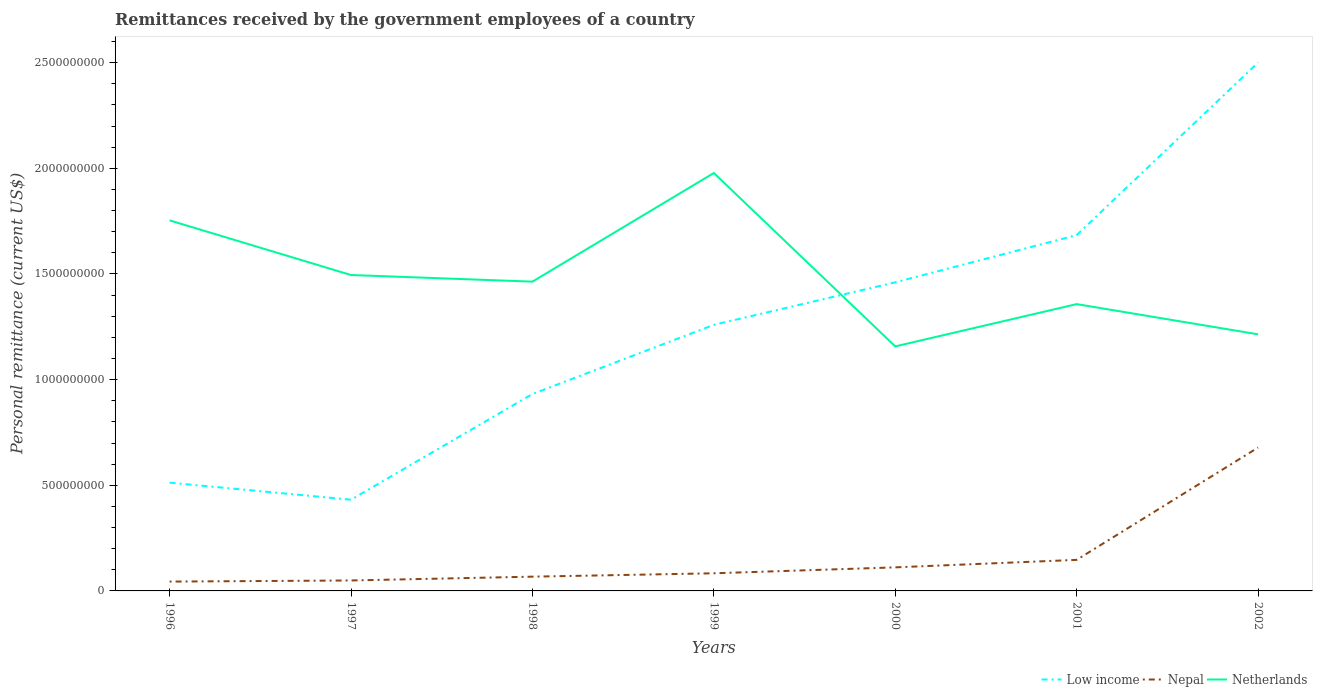Across all years, what is the maximum remittances received by the government employees in Netherlands?
Make the answer very short. 1.16e+09. In which year was the remittances received by the government employees in Low income maximum?
Ensure brevity in your answer.  1997. What is the total remittances received by the government employees in Netherlands in the graph?
Provide a succinct answer. 7.63e+08. What is the difference between the highest and the second highest remittances received by the government employees in Netherlands?
Offer a terse response. 8.21e+08. Is the remittances received by the government employees in Nepal strictly greater than the remittances received by the government employees in Netherlands over the years?
Your answer should be very brief. Yes. How many lines are there?
Provide a succinct answer. 3. How many years are there in the graph?
Offer a terse response. 7. What is the difference between two consecutive major ticks on the Y-axis?
Offer a terse response. 5.00e+08. Are the values on the major ticks of Y-axis written in scientific E-notation?
Ensure brevity in your answer.  No. Does the graph contain any zero values?
Offer a very short reply. No. Does the graph contain grids?
Give a very brief answer. No. What is the title of the graph?
Give a very brief answer. Remittances received by the government employees of a country. What is the label or title of the X-axis?
Give a very brief answer. Years. What is the label or title of the Y-axis?
Your answer should be very brief. Personal remittance (current US$). What is the Personal remittance (current US$) in Low income in 1996?
Provide a short and direct response. 5.12e+08. What is the Personal remittance (current US$) of Nepal in 1996?
Your response must be concise. 4.42e+07. What is the Personal remittance (current US$) of Netherlands in 1996?
Provide a succinct answer. 1.75e+09. What is the Personal remittance (current US$) in Low income in 1997?
Give a very brief answer. 4.32e+08. What is the Personal remittance (current US$) of Nepal in 1997?
Your response must be concise. 4.95e+07. What is the Personal remittance (current US$) in Netherlands in 1997?
Your response must be concise. 1.50e+09. What is the Personal remittance (current US$) of Low income in 1998?
Keep it short and to the point. 9.32e+08. What is the Personal remittance (current US$) of Nepal in 1998?
Provide a short and direct response. 6.75e+07. What is the Personal remittance (current US$) of Netherlands in 1998?
Provide a succinct answer. 1.46e+09. What is the Personal remittance (current US$) in Low income in 1999?
Offer a terse response. 1.26e+09. What is the Personal remittance (current US$) of Nepal in 1999?
Ensure brevity in your answer.  8.35e+07. What is the Personal remittance (current US$) in Netherlands in 1999?
Your response must be concise. 1.98e+09. What is the Personal remittance (current US$) of Low income in 2000?
Offer a very short reply. 1.46e+09. What is the Personal remittance (current US$) in Nepal in 2000?
Make the answer very short. 1.11e+08. What is the Personal remittance (current US$) of Netherlands in 2000?
Give a very brief answer. 1.16e+09. What is the Personal remittance (current US$) in Low income in 2001?
Provide a succinct answer. 1.68e+09. What is the Personal remittance (current US$) in Nepal in 2001?
Offer a terse response. 1.47e+08. What is the Personal remittance (current US$) in Netherlands in 2001?
Your answer should be compact. 1.36e+09. What is the Personal remittance (current US$) in Low income in 2002?
Your answer should be very brief. 2.50e+09. What is the Personal remittance (current US$) in Nepal in 2002?
Offer a terse response. 6.78e+08. What is the Personal remittance (current US$) in Netherlands in 2002?
Ensure brevity in your answer.  1.21e+09. Across all years, what is the maximum Personal remittance (current US$) of Low income?
Your response must be concise. 2.50e+09. Across all years, what is the maximum Personal remittance (current US$) in Nepal?
Ensure brevity in your answer.  6.78e+08. Across all years, what is the maximum Personal remittance (current US$) in Netherlands?
Your answer should be compact. 1.98e+09. Across all years, what is the minimum Personal remittance (current US$) in Low income?
Make the answer very short. 4.32e+08. Across all years, what is the minimum Personal remittance (current US$) in Nepal?
Keep it short and to the point. 4.42e+07. Across all years, what is the minimum Personal remittance (current US$) in Netherlands?
Provide a succinct answer. 1.16e+09. What is the total Personal remittance (current US$) of Low income in the graph?
Your answer should be compact. 8.78e+09. What is the total Personal remittance (current US$) of Nepal in the graph?
Provide a short and direct response. 1.18e+09. What is the total Personal remittance (current US$) of Netherlands in the graph?
Keep it short and to the point. 1.04e+1. What is the difference between the Personal remittance (current US$) of Low income in 1996 and that in 1997?
Keep it short and to the point. 8.07e+07. What is the difference between the Personal remittance (current US$) of Nepal in 1996 and that in 1997?
Your answer should be very brief. -5.30e+06. What is the difference between the Personal remittance (current US$) of Netherlands in 1996 and that in 1997?
Provide a short and direct response. 2.59e+08. What is the difference between the Personal remittance (current US$) in Low income in 1996 and that in 1998?
Offer a very short reply. -4.19e+08. What is the difference between the Personal remittance (current US$) in Nepal in 1996 and that in 1998?
Provide a short and direct response. -2.33e+07. What is the difference between the Personal remittance (current US$) of Netherlands in 1996 and that in 1998?
Your answer should be very brief. 2.90e+08. What is the difference between the Personal remittance (current US$) in Low income in 1996 and that in 1999?
Offer a terse response. -7.47e+08. What is the difference between the Personal remittance (current US$) in Nepal in 1996 and that in 1999?
Ensure brevity in your answer.  -3.93e+07. What is the difference between the Personal remittance (current US$) of Netherlands in 1996 and that in 1999?
Offer a terse response. -2.24e+08. What is the difference between the Personal remittance (current US$) in Low income in 1996 and that in 2000?
Keep it short and to the point. -9.48e+08. What is the difference between the Personal remittance (current US$) in Nepal in 1996 and that in 2000?
Provide a succinct answer. -6.73e+07. What is the difference between the Personal remittance (current US$) in Netherlands in 1996 and that in 2000?
Your answer should be compact. 5.96e+08. What is the difference between the Personal remittance (current US$) of Low income in 1996 and that in 2001?
Give a very brief answer. -1.17e+09. What is the difference between the Personal remittance (current US$) in Nepal in 1996 and that in 2001?
Your response must be concise. -1.03e+08. What is the difference between the Personal remittance (current US$) in Netherlands in 1996 and that in 2001?
Offer a very short reply. 3.96e+08. What is the difference between the Personal remittance (current US$) of Low income in 1996 and that in 2002?
Your answer should be compact. -1.99e+09. What is the difference between the Personal remittance (current US$) in Nepal in 1996 and that in 2002?
Make the answer very short. -6.34e+08. What is the difference between the Personal remittance (current US$) of Netherlands in 1996 and that in 2002?
Your response must be concise. 5.39e+08. What is the difference between the Personal remittance (current US$) of Low income in 1997 and that in 1998?
Keep it short and to the point. -5.00e+08. What is the difference between the Personal remittance (current US$) of Nepal in 1997 and that in 1998?
Offer a very short reply. -1.80e+07. What is the difference between the Personal remittance (current US$) in Netherlands in 1997 and that in 1998?
Give a very brief answer. 3.13e+07. What is the difference between the Personal remittance (current US$) in Low income in 1997 and that in 1999?
Provide a short and direct response. -8.28e+08. What is the difference between the Personal remittance (current US$) of Nepal in 1997 and that in 1999?
Your response must be concise. -3.40e+07. What is the difference between the Personal remittance (current US$) of Netherlands in 1997 and that in 1999?
Your answer should be compact. -4.83e+08. What is the difference between the Personal remittance (current US$) of Low income in 1997 and that in 2000?
Your answer should be compact. -1.03e+09. What is the difference between the Personal remittance (current US$) of Nepal in 1997 and that in 2000?
Your answer should be very brief. -6.20e+07. What is the difference between the Personal remittance (current US$) of Netherlands in 1997 and that in 2000?
Provide a short and direct response. 3.38e+08. What is the difference between the Personal remittance (current US$) of Low income in 1997 and that in 2001?
Your answer should be compact. -1.25e+09. What is the difference between the Personal remittance (current US$) in Nepal in 1997 and that in 2001?
Your response must be concise. -9.75e+07. What is the difference between the Personal remittance (current US$) of Netherlands in 1997 and that in 2001?
Make the answer very short. 1.38e+08. What is the difference between the Personal remittance (current US$) of Low income in 1997 and that in 2002?
Make the answer very short. -2.07e+09. What is the difference between the Personal remittance (current US$) in Nepal in 1997 and that in 2002?
Make the answer very short. -6.29e+08. What is the difference between the Personal remittance (current US$) of Netherlands in 1997 and that in 2002?
Your answer should be very brief. 2.81e+08. What is the difference between the Personal remittance (current US$) of Low income in 1998 and that in 1999?
Keep it short and to the point. -3.27e+08. What is the difference between the Personal remittance (current US$) in Nepal in 1998 and that in 1999?
Your answer should be compact. -1.60e+07. What is the difference between the Personal remittance (current US$) of Netherlands in 1998 and that in 1999?
Offer a very short reply. -5.14e+08. What is the difference between the Personal remittance (current US$) of Low income in 1998 and that in 2000?
Your response must be concise. -5.29e+08. What is the difference between the Personal remittance (current US$) of Nepal in 1998 and that in 2000?
Offer a very short reply. -4.40e+07. What is the difference between the Personal remittance (current US$) of Netherlands in 1998 and that in 2000?
Keep it short and to the point. 3.06e+08. What is the difference between the Personal remittance (current US$) of Low income in 1998 and that in 2001?
Make the answer very short. -7.52e+08. What is the difference between the Personal remittance (current US$) of Nepal in 1998 and that in 2001?
Your answer should be very brief. -7.95e+07. What is the difference between the Personal remittance (current US$) in Netherlands in 1998 and that in 2001?
Offer a terse response. 1.06e+08. What is the difference between the Personal remittance (current US$) of Low income in 1998 and that in 2002?
Your response must be concise. -1.57e+09. What is the difference between the Personal remittance (current US$) of Nepal in 1998 and that in 2002?
Offer a terse response. -6.11e+08. What is the difference between the Personal remittance (current US$) in Netherlands in 1998 and that in 2002?
Your answer should be very brief. 2.49e+08. What is the difference between the Personal remittance (current US$) in Low income in 1999 and that in 2000?
Provide a succinct answer. -2.01e+08. What is the difference between the Personal remittance (current US$) of Nepal in 1999 and that in 2000?
Make the answer very short. -2.80e+07. What is the difference between the Personal remittance (current US$) of Netherlands in 1999 and that in 2000?
Ensure brevity in your answer.  8.21e+08. What is the difference between the Personal remittance (current US$) in Low income in 1999 and that in 2001?
Your answer should be very brief. -4.25e+08. What is the difference between the Personal remittance (current US$) of Nepal in 1999 and that in 2001?
Keep it short and to the point. -6.35e+07. What is the difference between the Personal remittance (current US$) in Netherlands in 1999 and that in 2001?
Give a very brief answer. 6.20e+08. What is the difference between the Personal remittance (current US$) in Low income in 1999 and that in 2002?
Your response must be concise. -1.24e+09. What is the difference between the Personal remittance (current US$) in Nepal in 1999 and that in 2002?
Give a very brief answer. -5.95e+08. What is the difference between the Personal remittance (current US$) of Netherlands in 1999 and that in 2002?
Offer a very short reply. 7.63e+08. What is the difference between the Personal remittance (current US$) of Low income in 2000 and that in 2001?
Offer a terse response. -2.23e+08. What is the difference between the Personal remittance (current US$) of Nepal in 2000 and that in 2001?
Give a very brief answer. -3.55e+07. What is the difference between the Personal remittance (current US$) of Netherlands in 2000 and that in 2001?
Your answer should be very brief. -2.00e+08. What is the difference between the Personal remittance (current US$) of Low income in 2000 and that in 2002?
Offer a very short reply. -1.04e+09. What is the difference between the Personal remittance (current US$) in Nepal in 2000 and that in 2002?
Keep it short and to the point. -5.67e+08. What is the difference between the Personal remittance (current US$) in Netherlands in 2000 and that in 2002?
Your answer should be compact. -5.71e+07. What is the difference between the Personal remittance (current US$) in Low income in 2001 and that in 2002?
Provide a succinct answer. -8.17e+08. What is the difference between the Personal remittance (current US$) in Nepal in 2001 and that in 2002?
Make the answer very short. -5.32e+08. What is the difference between the Personal remittance (current US$) of Netherlands in 2001 and that in 2002?
Provide a short and direct response. 1.43e+08. What is the difference between the Personal remittance (current US$) of Low income in 1996 and the Personal remittance (current US$) of Nepal in 1997?
Your response must be concise. 4.63e+08. What is the difference between the Personal remittance (current US$) in Low income in 1996 and the Personal remittance (current US$) in Netherlands in 1997?
Your answer should be compact. -9.83e+08. What is the difference between the Personal remittance (current US$) in Nepal in 1996 and the Personal remittance (current US$) in Netherlands in 1997?
Offer a terse response. -1.45e+09. What is the difference between the Personal remittance (current US$) of Low income in 1996 and the Personal remittance (current US$) of Nepal in 1998?
Make the answer very short. 4.45e+08. What is the difference between the Personal remittance (current US$) of Low income in 1996 and the Personal remittance (current US$) of Netherlands in 1998?
Keep it short and to the point. -9.51e+08. What is the difference between the Personal remittance (current US$) of Nepal in 1996 and the Personal remittance (current US$) of Netherlands in 1998?
Your response must be concise. -1.42e+09. What is the difference between the Personal remittance (current US$) of Low income in 1996 and the Personal remittance (current US$) of Nepal in 1999?
Give a very brief answer. 4.29e+08. What is the difference between the Personal remittance (current US$) of Low income in 1996 and the Personal remittance (current US$) of Netherlands in 1999?
Offer a terse response. -1.47e+09. What is the difference between the Personal remittance (current US$) of Nepal in 1996 and the Personal remittance (current US$) of Netherlands in 1999?
Your answer should be very brief. -1.93e+09. What is the difference between the Personal remittance (current US$) of Low income in 1996 and the Personal remittance (current US$) of Nepal in 2000?
Keep it short and to the point. 4.01e+08. What is the difference between the Personal remittance (current US$) of Low income in 1996 and the Personal remittance (current US$) of Netherlands in 2000?
Provide a short and direct response. -6.45e+08. What is the difference between the Personal remittance (current US$) in Nepal in 1996 and the Personal remittance (current US$) in Netherlands in 2000?
Offer a very short reply. -1.11e+09. What is the difference between the Personal remittance (current US$) of Low income in 1996 and the Personal remittance (current US$) of Nepal in 2001?
Your response must be concise. 3.65e+08. What is the difference between the Personal remittance (current US$) of Low income in 1996 and the Personal remittance (current US$) of Netherlands in 2001?
Your answer should be compact. -8.45e+08. What is the difference between the Personal remittance (current US$) of Nepal in 1996 and the Personal remittance (current US$) of Netherlands in 2001?
Keep it short and to the point. -1.31e+09. What is the difference between the Personal remittance (current US$) of Low income in 1996 and the Personal remittance (current US$) of Nepal in 2002?
Your answer should be compact. -1.66e+08. What is the difference between the Personal remittance (current US$) of Low income in 1996 and the Personal remittance (current US$) of Netherlands in 2002?
Keep it short and to the point. -7.02e+08. What is the difference between the Personal remittance (current US$) in Nepal in 1996 and the Personal remittance (current US$) in Netherlands in 2002?
Provide a short and direct response. -1.17e+09. What is the difference between the Personal remittance (current US$) of Low income in 1997 and the Personal remittance (current US$) of Nepal in 1998?
Make the answer very short. 3.64e+08. What is the difference between the Personal remittance (current US$) of Low income in 1997 and the Personal remittance (current US$) of Netherlands in 1998?
Give a very brief answer. -1.03e+09. What is the difference between the Personal remittance (current US$) in Nepal in 1997 and the Personal remittance (current US$) in Netherlands in 1998?
Offer a terse response. -1.41e+09. What is the difference between the Personal remittance (current US$) in Low income in 1997 and the Personal remittance (current US$) in Nepal in 1999?
Offer a terse response. 3.48e+08. What is the difference between the Personal remittance (current US$) in Low income in 1997 and the Personal remittance (current US$) in Netherlands in 1999?
Offer a terse response. -1.55e+09. What is the difference between the Personal remittance (current US$) in Nepal in 1997 and the Personal remittance (current US$) in Netherlands in 1999?
Provide a short and direct response. -1.93e+09. What is the difference between the Personal remittance (current US$) of Low income in 1997 and the Personal remittance (current US$) of Nepal in 2000?
Ensure brevity in your answer.  3.20e+08. What is the difference between the Personal remittance (current US$) of Low income in 1997 and the Personal remittance (current US$) of Netherlands in 2000?
Offer a terse response. -7.26e+08. What is the difference between the Personal remittance (current US$) of Nepal in 1997 and the Personal remittance (current US$) of Netherlands in 2000?
Give a very brief answer. -1.11e+09. What is the difference between the Personal remittance (current US$) in Low income in 1997 and the Personal remittance (current US$) in Nepal in 2001?
Offer a terse response. 2.85e+08. What is the difference between the Personal remittance (current US$) of Low income in 1997 and the Personal remittance (current US$) of Netherlands in 2001?
Keep it short and to the point. -9.26e+08. What is the difference between the Personal remittance (current US$) in Nepal in 1997 and the Personal remittance (current US$) in Netherlands in 2001?
Make the answer very short. -1.31e+09. What is the difference between the Personal remittance (current US$) of Low income in 1997 and the Personal remittance (current US$) of Nepal in 2002?
Your response must be concise. -2.47e+08. What is the difference between the Personal remittance (current US$) of Low income in 1997 and the Personal remittance (current US$) of Netherlands in 2002?
Your answer should be compact. -7.83e+08. What is the difference between the Personal remittance (current US$) of Nepal in 1997 and the Personal remittance (current US$) of Netherlands in 2002?
Your answer should be compact. -1.16e+09. What is the difference between the Personal remittance (current US$) of Low income in 1998 and the Personal remittance (current US$) of Nepal in 1999?
Your answer should be compact. 8.48e+08. What is the difference between the Personal remittance (current US$) of Low income in 1998 and the Personal remittance (current US$) of Netherlands in 1999?
Keep it short and to the point. -1.05e+09. What is the difference between the Personal remittance (current US$) of Nepal in 1998 and the Personal remittance (current US$) of Netherlands in 1999?
Provide a short and direct response. -1.91e+09. What is the difference between the Personal remittance (current US$) in Low income in 1998 and the Personal remittance (current US$) in Nepal in 2000?
Make the answer very short. 8.20e+08. What is the difference between the Personal remittance (current US$) in Low income in 1998 and the Personal remittance (current US$) in Netherlands in 2000?
Your response must be concise. -2.25e+08. What is the difference between the Personal remittance (current US$) in Nepal in 1998 and the Personal remittance (current US$) in Netherlands in 2000?
Keep it short and to the point. -1.09e+09. What is the difference between the Personal remittance (current US$) in Low income in 1998 and the Personal remittance (current US$) in Nepal in 2001?
Provide a short and direct response. 7.85e+08. What is the difference between the Personal remittance (current US$) in Low income in 1998 and the Personal remittance (current US$) in Netherlands in 2001?
Offer a terse response. -4.25e+08. What is the difference between the Personal remittance (current US$) of Nepal in 1998 and the Personal remittance (current US$) of Netherlands in 2001?
Keep it short and to the point. -1.29e+09. What is the difference between the Personal remittance (current US$) in Low income in 1998 and the Personal remittance (current US$) in Nepal in 2002?
Ensure brevity in your answer.  2.53e+08. What is the difference between the Personal remittance (current US$) of Low income in 1998 and the Personal remittance (current US$) of Netherlands in 2002?
Offer a very short reply. -2.82e+08. What is the difference between the Personal remittance (current US$) in Nepal in 1998 and the Personal remittance (current US$) in Netherlands in 2002?
Keep it short and to the point. -1.15e+09. What is the difference between the Personal remittance (current US$) in Low income in 1999 and the Personal remittance (current US$) in Nepal in 2000?
Give a very brief answer. 1.15e+09. What is the difference between the Personal remittance (current US$) of Low income in 1999 and the Personal remittance (current US$) of Netherlands in 2000?
Give a very brief answer. 1.02e+08. What is the difference between the Personal remittance (current US$) in Nepal in 1999 and the Personal remittance (current US$) in Netherlands in 2000?
Give a very brief answer. -1.07e+09. What is the difference between the Personal remittance (current US$) of Low income in 1999 and the Personal remittance (current US$) of Nepal in 2001?
Make the answer very short. 1.11e+09. What is the difference between the Personal remittance (current US$) in Low income in 1999 and the Personal remittance (current US$) in Netherlands in 2001?
Offer a very short reply. -9.81e+07. What is the difference between the Personal remittance (current US$) of Nepal in 1999 and the Personal remittance (current US$) of Netherlands in 2001?
Give a very brief answer. -1.27e+09. What is the difference between the Personal remittance (current US$) in Low income in 1999 and the Personal remittance (current US$) in Nepal in 2002?
Offer a very short reply. 5.81e+08. What is the difference between the Personal remittance (current US$) in Low income in 1999 and the Personal remittance (current US$) in Netherlands in 2002?
Offer a terse response. 4.49e+07. What is the difference between the Personal remittance (current US$) of Nepal in 1999 and the Personal remittance (current US$) of Netherlands in 2002?
Ensure brevity in your answer.  -1.13e+09. What is the difference between the Personal remittance (current US$) of Low income in 2000 and the Personal remittance (current US$) of Nepal in 2001?
Offer a very short reply. 1.31e+09. What is the difference between the Personal remittance (current US$) of Low income in 2000 and the Personal remittance (current US$) of Netherlands in 2001?
Offer a terse response. 1.03e+08. What is the difference between the Personal remittance (current US$) in Nepal in 2000 and the Personal remittance (current US$) in Netherlands in 2001?
Ensure brevity in your answer.  -1.25e+09. What is the difference between the Personal remittance (current US$) of Low income in 2000 and the Personal remittance (current US$) of Nepal in 2002?
Make the answer very short. 7.82e+08. What is the difference between the Personal remittance (current US$) of Low income in 2000 and the Personal remittance (current US$) of Netherlands in 2002?
Provide a short and direct response. 2.46e+08. What is the difference between the Personal remittance (current US$) of Nepal in 2000 and the Personal remittance (current US$) of Netherlands in 2002?
Provide a succinct answer. -1.10e+09. What is the difference between the Personal remittance (current US$) of Low income in 2001 and the Personal remittance (current US$) of Nepal in 2002?
Give a very brief answer. 1.01e+09. What is the difference between the Personal remittance (current US$) in Low income in 2001 and the Personal remittance (current US$) in Netherlands in 2002?
Offer a terse response. 4.70e+08. What is the difference between the Personal remittance (current US$) in Nepal in 2001 and the Personal remittance (current US$) in Netherlands in 2002?
Offer a terse response. -1.07e+09. What is the average Personal remittance (current US$) in Low income per year?
Your response must be concise. 1.25e+09. What is the average Personal remittance (current US$) of Nepal per year?
Keep it short and to the point. 1.69e+08. What is the average Personal remittance (current US$) of Netherlands per year?
Your response must be concise. 1.49e+09. In the year 1996, what is the difference between the Personal remittance (current US$) in Low income and Personal remittance (current US$) in Nepal?
Make the answer very short. 4.68e+08. In the year 1996, what is the difference between the Personal remittance (current US$) of Low income and Personal remittance (current US$) of Netherlands?
Offer a very short reply. -1.24e+09. In the year 1996, what is the difference between the Personal remittance (current US$) of Nepal and Personal remittance (current US$) of Netherlands?
Offer a terse response. -1.71e+09. In the year 1997, what is the difference between the Personal remittance (current US$) in Low income and Personal remittance (current US$) in Nepal?
Make the answer very short. 3.82e+08. In the year 1997, what is the difference between the Personal remittance (current US$) in Low income and Personal remittance (current US$) in Netherlands?
Your response must be concise. -1.06e+09. In the year 1997, what is the difference between the Personal remittance (current US$) of Nepal and Personal remittance (current US$) of Netherlands?
Your response must be concise. -1.45e+09. In the year 1998, what is the difference between the Personal remittance (current US$) of Low income and Personal remittance (current US$) of Nepal?
Make the answer very short. 8.64e+08. In the year 1998, what is the difference between the Personal remittance (current US$) in Low income and Personal remittance (current US$) in Netherlands?
Your answer should be very brief. -5.32e+08. In the year 1998, what is the difference between the Personal remittance (current US$) of Nepal and Personal remittance (current US$) of Netherlands?
Provide a short and direct response. -1.40e+09. In the year 1999, what is the difference between the Personal remittance (current US$) in Low income and Personal remittance (current US$) in Nepal?
Provide a succinct answer. 1.18e+09. In the year 1999, what is the difference between the Personal remittance (current US$) of Low income and Personal remittance (current US$) of Netherlands?
Your answer should be very brief. -7.19e+08. In the year 1999, what is the difference between the Personal remittance (current US$) in Nepal and Personal remittance (current US$) in Netherlands?
Provide a short and direct response. -1.89e+09. In the year 2000, what is the difference between the Personal remittance (current US$) of Low income and Personal remittance (current US$) of Nepal?
Your answer should be very brief. 1.35e+09. In the year 2000, what is the difference between the Personal remittance (current US$) of Low income and Personal remittance (current US$) of Netherlands?
Your answer should be very brief. 3.03e+08. In the year 2000, what is the difference between the Personal remittance (current US$) in Nepal and Personal remittance (current US$) in Netherlands?
Your response must be concise. -1.05e+09. In the year 2001, what is the difference between the Personal remittance (current US$) of Low income and Personal remittance (current US$) of Nepal?
Your answer should be very brief. 1.54e+09. In the year 2001, what is the difference between the Personal remittance (current US$) in Low income and Personal remittance (current US$) in Netherlands?
Keep it short and to the point. 3.27e+08. In the year 2001, what is the difference between the Personal remittance (current US$) of Nepal and Personal remittance (current US$) of Netherlands?
Your answer should be compact. -1.21e+09. In the year 2002, what is the difference between the Personal remittance (current US$) in Low income and Personal remittance (current US$) in Nepal?
Offer a terse response. 1.82e+09. In the year 2002, what is the difference between the Personal remittance (current US$) of Low income and Personal remittance (current US$) of Netherlands?
Give a very brief answer. 1.29e+09. In the year 2002, what is the difference between the Personal remittance (current US$) in Nepal and Personal remittance (current US$) in Netherlands?
Ensure brevity in your answer.  -5.36e+08. What is the ratio of the Personal remittance (current US$) in Low income in 1996 to that in 1997?
Your answer should be very brief. 1.19. What is the ratio of the Personal remittance (current US$) in Nepal in 1996 to that in 1997?
Offer a very short reply. 0.89. What is the ratio of the Personal remittance (current US$) of Netherlands in 1996 to that in 1997?
Keep it short and to the point. 1.17. What is the ratio of the Personal remittance (current US$) of Low income in 1996 to that in 1998?
Your answer should be very brief. 0.55. What is the ratio of the Personal remittance (current US$) of Nepal in 1996 to that in 1998?
Ensure brevity in your answer.  0.65. What is the ratio of the Personal remittance (current US$) of Netherlands in 1996 to that in 1998?
Keep it short and to the point. 1.2. What is the ratio of the Personal remittance (current US$) in Low income in 1996 to that in 1999?
Offer a terse response. 0.41. What is the ratio of the Personal remittance (current US$) of Nepal in 1996 to that in 1999?
Your answer should be compact. 0.53. What is the ratio of the Personal remittance (current US$) in Netherlands in 1996 to that in 1999?
Offer a terse response. 0.89. What is the ratio of the Personal remittance (current US$) in Low income in 1996 to that in 2000?
Give a very brief answer. 0.35. What is the ratio of the Personal remittance (current US$) of Nepal in 1996 to that in 2000?
Make the answer very short. 0.4. What is the ratio of the Personal remittance (current US$) in Netherlands in 1996 to that in 2000?
Give a very brief answer. 1.52. What is the ratio of the Personal remittance (current US$) in Low income in 1996 to that in 2001?
Your answer should be compact. 0.3. What is the ratio of the Personal remittance (current US$) of Nepal in 1996 to that in 2001?
Provide a short and direct response. 0.3. What is the ratio of the Personal remittance (current US$) in Netherlands in 1996 to that in 2001?
Your answer should be compact. 1.29. What is the ratio of the Personal remittance (current US$) of Low income in 1996 to that in 2002?
Make the answer very short. 0.2. What is the ratio of the Personal remittance (current US$) of Nepal in 1996 to that in 2002?
Your answer should be very brief. 0.07. What is the ratio of the Personal remittance (current US$) in Netherlands in 1996 to that in 2002?
Your response must be concise. 1.44. What is the ratio of the Personal remittance (current US$) in Low income in 1997 to that in 1998?
Your answer should be very brief. 0.46. What is the ratio of the Personal remittance (current US$) in Nepal in 1997 to that in 1998?
Your answer should be very brief. 0.73. What is the ratio of the Personal remittance (current US$) in Netherlands in 1997 to that in 1998?
Provide a succinct answer. 1.02. What is the ratio of the Personal remittance (current US$) of Low income in 1997 to that in 1999?
Ensure brevity in your answer.  0.34. What is the ratio of the Personal remittance (current US$) in Nepal in 1997 to that in 1999?
Make the answer very short. 0.59. What is the ratio of the Personal remittance (current US$) of Netherlands in 1997 to that in 1999?
Your response must be concise. 0.76. What is the ratio of the Personal remittance (current US$) in Low income in 1997 to that in 2000?
Provide a short and direct response. 0.3. What is the ratio of the Personal remittance (current US$) in Nepal in 1997 to that in 2000?
Offer a terse response. 0.44. What is the ratio of the Personal remittance (current US$) of Netherlands in 1997 to that in 2000?
Your answer should be compact. 1.29. What is the ratio of the Personal remittance (current US$) in Low income in 1997 to that in 2001?
Offer a very short reply. 0.26. What is the ratio of the Personal remittance (current US$) of Nepal in 1997 to that in 2001?
Provide a short and direct response. 0.34. What is the ratio of the Personal remittance (current US$) in Netherlands in 1997 to that in 2001?
Provide a succinct answer. 1.1. What is the ratio of the Personal remittance (current US$) in Low income in 1997 to that in 2002?
Provide a succinct answer. 0.17. What is the ratio of the Personal remittance (current US$) of Nepal in 1997 to that in 2002?
Offer a terse response. 0.07. What is the ratio of the Personal remittance (current US$) in Netherlands in 1997 to that in 2002?
Ensure brevity in your answer.  1.23. What is the ratio of the Personal remittance (current US$) in Low income in 1998 to that in 1999?
Make the answer very short. 0.74. What is the ratio of the Personal remittance (current US$) of Nepal in 1998 to that in 1999?
Ensure brevity in your answer.  0.81. What is the ratio of the Personal remittance (current US$) of Netherlands in 1998 to that in 1999?
Offer a very short reply. 0.74. What is the ratio of the Personal remittance (current US$) in Low income in 1998 to that in 2000?
Provide a short and direct response. 0.64. What is the ratio of the Personal remittance (current US$) of Nepal in 1998 to that in 2000?
Keep it short and to the point. 0.61. What is the ratio of the Personal remittance (current US$) in Netherlands in 1998 to that in 2000?
Offer a very short reply. 1.26. What is the ratio of the Personal remittance (current US$) in Low income in 1998 to that in 2001?
Ensure brevity in your answer.  0.55. What is the ratio of the Personal remittance (current US$) in Nepal in 1998 to that in 2001?
Your answer should be very brief. 0.46. What is the ratio of the Personal remittance (current US$) in Netherlands in 1998 to that in 2001?
Give a very brief answer. 1.08. What is the ratio of the Personal remittance (current US$) in Low income in 1998 to that in 2002?
Provide a short and direct response. 0.37. What is the ratio of the Personal remittance (current US$) in Nepal in 1998 to that in 2002?
Provide a short and direct response. 0.1. What is the ratio of the Personal remittance (current US$) in Netherlands in 1998 to that in 2002?
Offer a terse response. 1.21. What is the ratio of the Personal remittance (current US$) of Low income in 1999 to that in 2000?
Ensure brevity in your answer.  0.86. What is the ratio of the Personal remittance (current US$) in Nepal in 1999 to that in 2000?
Give a very brief answer. 0.75. What is the ratio of the Personal remittance (current US$) in Netherlands in 1999 to that in 2000?
Provide a short and direct response. 1.71. What is the ratio of the Personal remittance (current US$) in Low income in 1999 to that in 2001?
Provide a short and direct response. 0.75. What is the ratio of the Personal remittance (current US$) in Nepal in 1999 to that in 2001?
Keep it short and to the point. 0.57. What is the ratio of the Personal remittance (current US$) of Netherlands in 1999 to that in 2001?
Your answer should be very brief. 1.46. What is the ratio of the Personal remittance (current US$) of Low income in 1999 to that in 2002?
Your answer should be compact. 0.5. What is the ratio of the Personal remittance (current US$) in Nepal in 1999 to that in 2002?
Offer a very short reply. 0.12. What is the ratio of the Personal remittance (current US$) in Netherlands in 1999 to that in 2002?
Offer a terse response. 1.63. What is the ratio of the Personal remittance (current US$) of Low income in 2000 to that in 2001?
Make the answer very short. 0.87. What is the ratio of the Personal remittance (current US$) of Nepal in 2000 to that in 2001?
Offer a terse response. 0.76. What is the ratio of the Personal remittance (current US$) of Netherlands in 2000 to that in 2001?
Ensure brevity in your answer.  0.85. What is the ratio of the Personal remittance (current US$) in Low income in 2000 to that in 2002?
Keep it short and to the point. 0.58. What is the ratio of the Personal remittance (current US$) of Nepal in 2000 to that in 2002?
Make the answer very short. 0.16. What is the ratio of the Personal remittance (current US$) of Netherlands in 2000 to that in 2002?
Your response must be concise. 0.95. What is the ratio of the Personal remittance (current US$) of Low income in 2001 to that in 2002?
Provide a short and direct response. 0.67. What is the ratio of the Personal remittance (current US$) of Nepal in 2001 to that in 2002?
Make the answer very short. 0.22. What is the ratio of the Personal remittance (current US$) of Netherlands in 2001 to that in 2002?
Keep it short and to the point. 1.12. What is the difference between the highest and the second highest Personal remittance (current US$) in Low income?
Your response must be concise. 8.17e+08. What is the difference between the highest and the second highest Personal remittance (current US$) of Nepal?
Offer a terse response. 5.32e+08. What is the difference between the highest and the second highest Personal remittance (current US$) in Netherlands?
Make the answer very short. 2.24e+08. What is the difference between the highest and the lowest Personal remittance (current US$) of Low income?
Provide a succinct answer. 2.07e+09. What is the difference between the highest and the lowest Personal remittance (current US$) of Nepal?
Give a very brief answer. 6.34e+08. What is the difference between the highest and the lowest Personal remittance (current US$) in Netherlands?
Make the answer very short. 8.21e+08. 